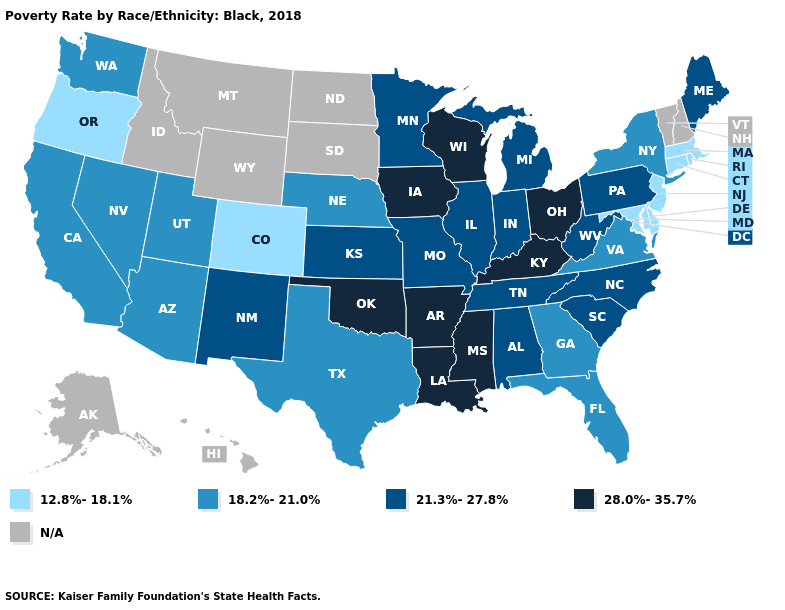What is the lowest value in the South?
Keep it brief. 12.8%-18.1%. Is the legend a continuous bar?
Give a very brief answer. No. What is the value of Nevada?
Quick response, please. 18.2%-21.0%. Name the states that have a value in the range 18.2%-21.0%?
Short answer required. Arizona, California, Florida, Georgia, Nebraska, Nevada, New York, Texas, Utah, Virginia, Washington. What is the lowest value in states that border Nebraska?
Quick response, please. 12.8%-18.1%. Does Nebraska have the lowest value in the MidWest?
Give a very brief answer. Yes. What is the value of Montana?
Concise answer only. N/A. What is the lowest value in the South?
Concise answer only. 12.8%-18.1%. Among the states that border California , which have the lowest value?
Short answer required. Oregon. What is the highest value in states that border Virginia?
Quick response, please. 28.0%-35.7%. Name the states that have a value in the range 28.0%-35.7%?
Concise answer only. Arkansas, Iowa, Kentucky, Louisiana, Mississippi, Ohio, Oklahoma, Wisconsin. What is the value of Missouri?
Give a very brief answer. 21.3%-27.8%. 